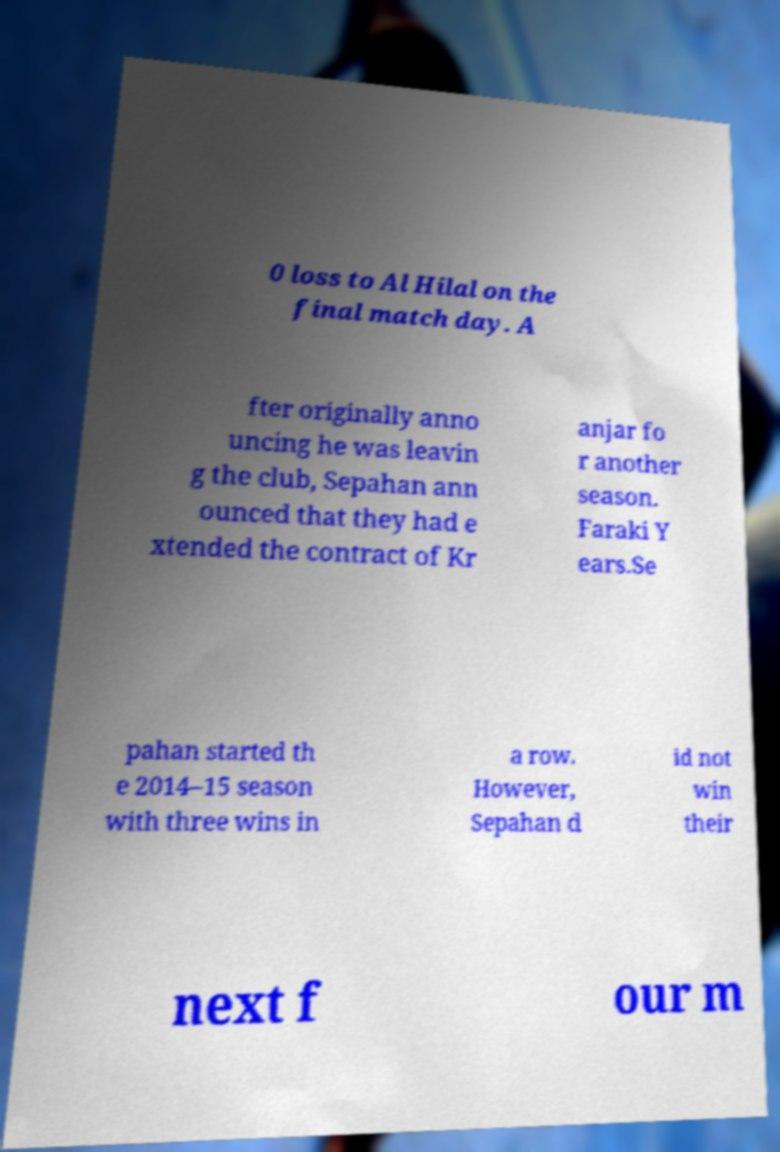Can you read and provide the text displayed in the image?This photo seems to have some interesting text. Can you extract and type it out for me? 0 loss to Al Hilal on the final match day. A fter originally anno uncing he was leavin g the club, Sepahan ann ounced that they had e xtended the contract of Kr anjar fo r another season. Faraki Y ears.Se pahan started th e 2014–15 season with three wins in a row. However, Sepahan d id not win their next f our m 